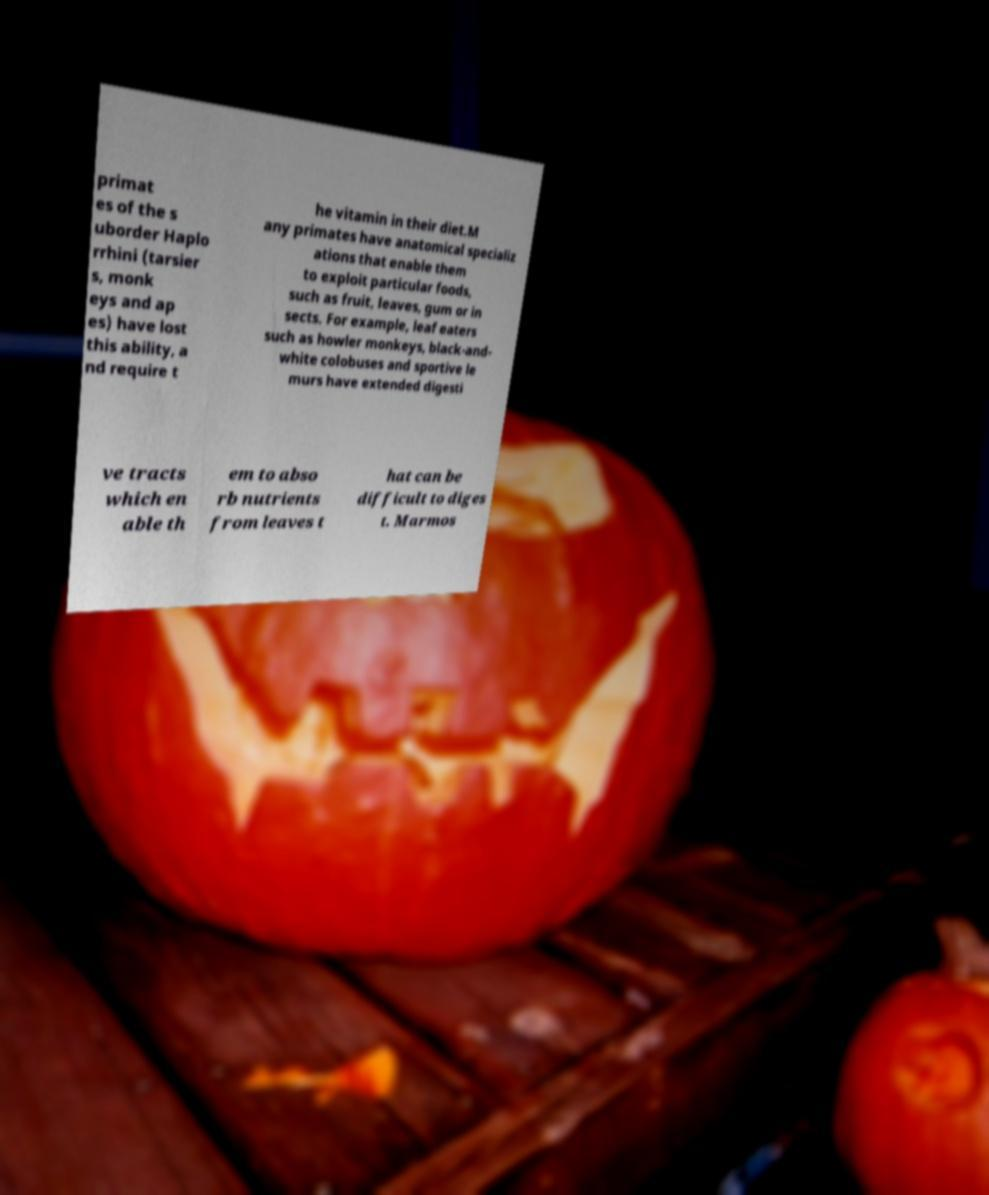Could you assist in decoding the text presented in this image and type it out clearly? primat es of the s uborder Haplo rrhini (tarsier s, monk eys and ap es) have lost this ability, a nd require t he vitamin in their diet.M any primates have anatomical specializ ations that enable them to exploit particular foods, such as fruit, leaves, gum or in sects. For example, leaf eaters such as howler monkeys, black-and- white colobuses and sportive le murs have extended digesti ve tracts which en able th em to abso rb nutrients from leaves t hat can be difficult to diges t. Marmos 